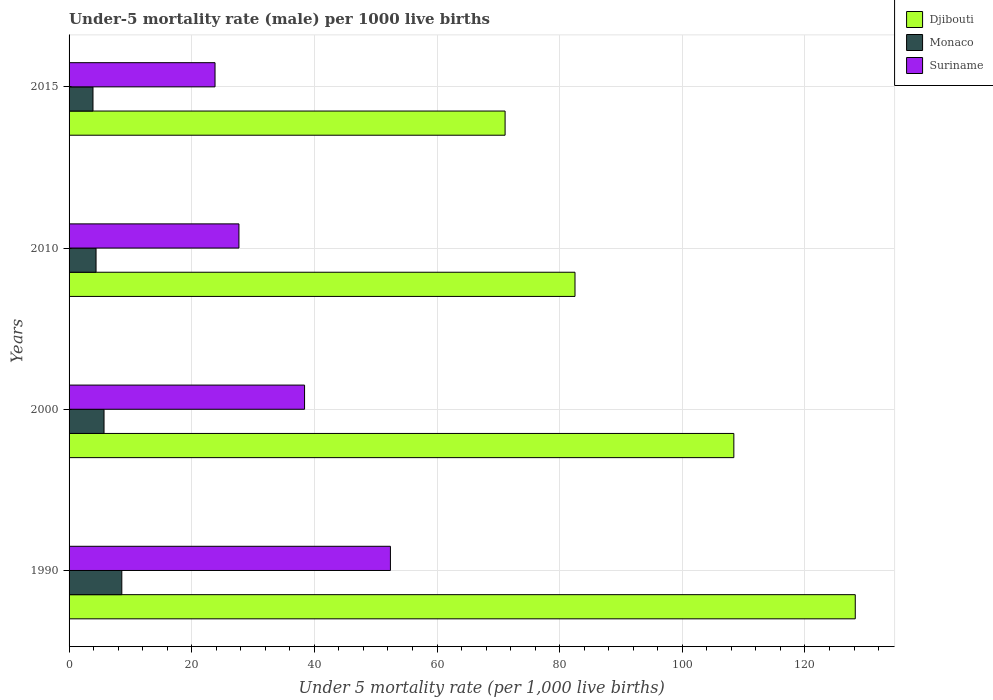How many different coloured bars are there?
Offer a very short reply. 3. How many groups of bars are there?
Offer a terse response. 4. Are the number of bars per tick equal to the number of legend labels?
Ensure brevity in your answer.  Yes. What is the label of the 2nd group of bars from the top?
Make the answer very short. 2010. Across all years, what is the minimum under-five mortality rate in Suriname?
Offer a very short reply. 23.8. In which year was the under-five mortality rate in Monaco maximum?
Provide a short and direct response. 1990. In which year was the under-five mortality rate in Monaco minimum?
Keep it short and to the point. 2015. What is the total under-five mortality rate in Djibouti in the graph?
Your answer should be very brief. 390.2. What is the difference between the under-five mortality rate in Djibouti in 1990 and that in 2010?
Your answer should be very brief. 45.7. What is the difference between the under-five mortality rate in Djibouti in 1990 and the under-five mortality rate in Suriname in 2010?
Keep it short and to the point. 100.5. What is the average under-five mortality rate in Djibouti per year?
Give a very brief answer. 97.55. In the year 2000, what is the difference between the under-five mortality rate in Suriname and under-five mortality rate in Djibouti?
Your response must be concise. -70. What is the ratio of the under-five mortality rate in Monaco in 2010 to that in 2015?
Offer a very short reply. 1.13. Is the difference between the under-five mortality rate in Suriname in 1990 and 2015 greater than the difference between the under-five mortality rate in Djibouti in 1990 and 2015?
Ensure brevity in your answer.  No. What is the difference between the highest and the second highest under-five mortality rate in Djibouti?
Offer a very short reply. 19.8. What is the difference between the highest and the lowest under-five mortality rate in Suriname?
Provide a succinct answer. 28.6. Is the sum of the under-five mortality rate in Djibouti in 2000 and 2010 greater than the maximum under-five mortality rate in Monaco across all years?
Your answer should be compact. Yes. What does the 3rd bar from the top in 2000 represents?
Give a very brief answer. Djibouti. What does the 2nd bar from the bottom in 1990 represents?
Ensure brevity in your answer.  Monaco. What is the difference between two consecutive major ticks on the X-axis?
Make the answer very short. 20. Does the graph contain grids?
Give a very brief answer. Yes. How many legend labels are there?
Make the answer very short. 3. What is the title of the graph?
Give a very brief answer. Under-5 mortality rate (male) per 1000 live births. Does "Antigua and Barbuda" appear as one of the legend labels in the graph?
Give a very brief answer. No. What is the label or title of the X-axis?
Provide a short and direct response. Under 5 mortality rate (per 1,0 live births). What is the Under 5 mortality rate (per 1,000 live births) in Djibouti in 1990?
Your answer should be compact. 128.2. What is the Under 5 mortality rate (per 1,000 live births) in Suriname in 1990?
Keep it short and to the point. 52.4. What is the Under 5 mortality rate (per 1,000 live births) in Djibouti in 2000?
Keep it short and to the point. 108.4. What is the Under 5 mortality rate (per 1,000 live births) in Monaco in 2000?
Offer a terse response. 5.7. What is the Under 5 mortality rate (per 1,000 live births) in Suriname in 2000?
Ensure brevity in your answer.  38.4. What is the Under 5 mortality rate (per 1,000 live births) in Djibouti in 2010?
Your response must be concise. 82.5. What is the Under 5 mortality rate (per 1,000 live births) in Monaco in 2010?
Your answer should be compact. 4.4. What is the Under 5 mortality rate (per 1,000 live births) in Suriname in 2010?
Your answer should be very brief. 27.7. What is the Under 5 mortality rate (per 1,000 live births) in Djibouti in 2015?
Provide a short and direct response. 71.1. What is the Under 5 mortality rate (per 1,000 live births) in Suriname in 2015?
Offer a very short reply. 23.8. Across all years, what is the maximum Under 5 mortality rate (per 1,000 live births) in Djibouti?
Offer a terse response. 128.2. Across all years, what is the maximum Under 5 mortality rate (per 1,000 live births) of Suriname?
Offer a terse response. 52.4. Across all years, what is the minimum Under 5 mortality rate (per 1,000 live births) of Djibouti?
Provide a succinct answer. 71.1. Across all years, what is the minimum Under 5 mortality rate (per 1,000 live births) of Monaco?
Provide a succinct answer. 3.9. Across all years, what is the minimum Under 5 mortality rate (per 1,000 live births) of Suriname?
Ensure brevity in your answer.  23.8. What is the total Under 5 mortality rate (per 1,000 live births) in Djibouti in the graph?
Provide a short and direct response. 390.2. What is the total Under 5 mortality rate (per 1,000 live births) in Monaco in the graph?
Give a very brief answer. 22.6. What is the total Under 5 mortality rate (per 1,000 live births) in Suriname in the graph?
Offer a terse response. 142.3. What is the difference between the Under 5 mortality rate (per 1,000 live births) of Djibouti in 1990 and that in 2000?
Keep it short and to the point. 19.8. What is the difference between the Under 5 mortality rate (per 1,000 live births) in Suriname in 1990 and that in 2000?
Your response must be concise. 14. What is the difference between the Under 5 mortality rate (per 1,000 live births) of Djibouti in 1990 and that in 2010?
Your answer should be very brief. 45.7. What is the difference between the Under 5 mortality rate (per 1,000 live births) of Monaco in 1990 and that in 2010?
Make the answer very short. 4.2. What is the difference between the Under 5 mortality rate (per 1,000 live births) of Suriname in 1990 and that in 2010?
Provide a short and direct response. 24.7. What is the difference between the Under 5 mortality rate (per 1,000 live births) of Djibouti in 1990 and that in 2015?
Your response must be concise. 57.1. What is the difference between the Under 5 mortality rate (per 1,000 live births) in Suriname in 1990 and that in 2015?
Your answer should be very brief. 28.6. What is the difference between the Under 5 mortality rate (per 1,000 live births) in Djibouti in 2000 and that in 2010?
Provide a short and direct response. 25.9. What is the difference between the Under 5 mortality rate (per 1,000 live births) of Suriname in 2000 and that in 2010?
Make the answer very short. 10.7. What is the difference between the Under 5 mortality rate (per 1,000 live births) in Djibouti in 2000 and that in 2015?
Your answer should be very brief. 37.3. What is the difference between the Under 5 mortality rate (per 1,000 live births) of Suriname in 2010 and that in 2015?
Offer a very short reply. 3.9. What is the difference between the Under 5 mortality rate (per 1,000 live births) of Djibouti in 1990 and the Under 5 mortality rate (per 1,000 live births) of Monaco in 2000?
Ensure brevity in your answer.  122.5. What is the difference between the Under 5 mortality rate (per 1,000 live births) of Djibouti in 1990 and the Under 5 mortality rate (per 1,000 live births) of Suriname in 2000?
Make the answer very short. 89.8. What is the difference between the Under 5 mortality rate (per 1,000 live births) of Monaco in 1990 and the Under 5 mortality rate (per 1,000 live births) of Suriname in 2000?
Offer a terse response. -29.8. What is the difference between the Under 5 mortality rate (per 1,000 live births) of Djibouti in 1990 and the Under 5 mortality rate (per 1,000 live births) of Monaco in 2010?
Keep it short and to the point. 123.8. What is the difference between the Under 5 mortality rate (per 1,000 live births) in Djibouti in 1990 and the Under 5 mortality rate (per 1,000 live births) in Suriname in 2010?
Give a very brief answer. 100.5. What is the difference between the Under 5 mortality rate (per 1,000 live births) of Monaco in 1990 and the Under 5 mortality rate (per 1,000 live births) of Suriname in 2010?
Ensure brevity in your answer.  -19.1. What is the difference between the Under 5 mortality rate (per 1,000 live births) of Djibouti in 1990 and the Under 5 mortality rate (per 1,000 live births) of Monaco in 2015?
Give a very brief answer. 124.3. What is the difference between the Under 5 mortality rate (per 1,000 live births) in Djibouti in 1990 and the Under 5 mortality rate (per 1,000 live births) in Suriname in 2015?
Offer a very short reply. 104.4. What is the difference between the Under 5 mortality rate (per 1,000 live births) of Monaco in 1990 and the Under 5 mortality rate (per 1,000 live births) of Suriname in 2015?
Your response must be concise. -15.2. What is the difference between the Under 5 mortality rate (per 1,000 live births) in Djibouti in 2000 and the Under 5 mortality rate (per 1,000 live births) in Monaco in 2010?
Give a very brief answer. 104. What is the difference between the Under 5 mortality rate (per 1,000 live births) of Djibouti in 2000 and the Under 5 mortality rate (per 1,000 live births) of Suriname in 2010?
Offer a terse response. 80.7. What is the difference between the Under 5 mortality rate (per 1,000 live births) in Monaco in 2000 and the Under 5 mortality rate (per 1,000 live births) in Suriname in 2010?
Give a very brief answer. -22. What is the difference between the Under 5 mortality rate (per 1,000 live births) in Djibouti in 2000 and the Under 5 mortality rate (per 1,000 live births) in Monaco in 2015?
Keep it short and to the point. 104.5. What is the difference between the Under 5 mortality rate (per 1,000 live births) in Djibouti in 2000 and the Under 5 mortality rate (per 1,000 live births) in Suriname in 2015?
Provide a succinct answer. 84.6. What is the difference between the Under 5 mortality rate (per 1,000 live births) of Monaco in 2000 and the Under 5 mortality rate (per 1,000 live births) of Suriname in 2015?
Your answer should be compact. -18.1. What is the difference between the Under 5 mortality rate (per 1,000 live births) of Djibouti in 2010 and the Under 5 mortality rate (per 1,000 live births) of Monaco in 2015?
Your answer should be compact. 78.6. What is the difference between the Under 5 mortality rate (per 1,000 live births) of Djibouti in 2010 and the Under 5 mortality rate (per 1,000 live births) of Suriname in 2015?
Ensure brevity in your answer.  58.7. What is the difference between the Under 5 mortality rate (per 1,000 live births) in Monaco in 2010 and the Under 5 mortality rate (per 1,000 live births) in Suriname in 2015?
Offer a terse response. -19.4. What is the average Under 5 mortality rate (per 1,000 live births) in Djibouti per year?
Offer a terse response. 97.55. What is the average Under 5 mortality rate (per 1,000 live births) in Monaco per year?
Make the answer very short. 5.65. What is the average Under 5 mortality rate (per 1,000 live births) in Suriname per year?
Ensure brevity in your answer.  35.58. In the year 1990, what is the difference between the Under 5 mortality rate (per 1,000 live births) in Djibouti and Under 5 mortality rate (per 1,000 live births) in Monaco?
Offer a very short reply. 119.6. In the year 1990, what is the difference between the Under 5 mortality rate (per 1,000 live births) of Djibouti and Under 5 mortality rate (per 1,000 live births) of Suriname?
Provide a short and direct response. 75.8. In the year 1990, what is the difference between the Under 5 mortality rate (per 1,000 live births) of Monaco and Under 5 mortality rate (per 1,000 live births) of Suriname?
Give a very brief answer. -43.8. In the year 2000, what is the difference between the Under 5 mortality rate (per 1,000 live births) of Djibouti and Under 5 mortality rate (per 1,000 live births) of Monaco?
Provide a succinct answer. 102.7. In the year 2000, what is the difference between the Under 5 mortality rate (per 1,000 live births) of Monaco and Under 5 mortality rate (per 1,000 live births) of Suriname?
Make the answer very short. -32.7. In the year 2010, what is the difference between the Under 5 mortality rate (per 1,000 live births) in Djibouti and Under 5 mortality rate (per 1,000 live births) in Monaco?
Offer a terse response. 78.1. In the year 2010, what is the difference between the Under 5 mortality rate (per 1,000 live births) in Djibouti and Under 5 mortality rate (per 1,000 live births) in Suriname?
Provide a short and direct response. 54.8. In the year 2010, what is the difference between the Under 5 mortality rate (per 1,000 live births) of Monaco and Under 5 mortality rate (per 1,000 live births) of Suriname?
Offer a terse response. -23.3. In the year 2015, what is the difference between the Under 5 mortality rate (per 1,000 live births) of Djibouti and Under 5 mortality rate (per 1,000 live births) of Monaco?
Give a very brief answer. 67.2. In the year 2015, what is the difference between the Under 5 mortality rate (per 1,000 live births) in Djibouti and Under 5 mortality rate (per 1,000 live births) in Suriname?
Keep it short and to the point. 47.3. In the year 2015, what is the difference between the Under 5 mortality rate (per 1,000 live births) of Monaco and Under 5 mortality rate (per 1,000 live births) of Suriname?
Make the answer very short. -19.9. What is the ratio of the Under 5 mortality rate (per 1,000 live births) in Djibouti in 1990 to that in 2000?
Offer a terse response. 1.18. What is the ratio of the Under 5 mortality rate (per 1,000 live births) of Monaco in 1990 to that in 2000?
Ensure brevity in your answer.  1.51. What is the ratio of the Under 5 mortality rate (per 1,000 live births) in Suriname in 1990 to that in 2000?
Provide a short and direct response. 1.36. What is the ratio of the Under 5 mortality rate (per 1,000 live births) in Djibouti in 1990 to that in 2010?
Provide a short and direct response. 1.55. What is the ratio of the Under 5 mortality rate (per 1,000 live births) in Monaco in 1990 to that in 2010?
Provide a short and direct response. 1.95. What is the ratio of the Under 5 mortality rate (per 1,000 live births) of Suriname in 1990 to that in 2010?
Offer a terse response. 1.89. What is the ratio of the Under 5 mortality rate (per 1,000 live births) of Djibouti in 1990 to that in 2015?
Your answer should be very brief. 1.8. What is the ratio of the Under 5 mortality rate (per 1,000 live births) in Monaco in 1990 to that in 2015?
Keep it short and to the point. 2.21. What is the ratio of the Under 5 mortality rate (per 1,000 live births) of Suriname in 1990 to that in 2015?
Your response must be concise. 2.2. What is the ratio of the Under 5 mortality rate (per 1,000 live births) in Djibouti in 2000 to that in 2010?
Your response must be concise. 1.31. What is the ratio of the Under 5 mortality rate (per 1,000 live births) in Monaco in 2000 to that in 2010?
Your answer should be compact. 1.3. What is the ratio of the Under 5 mortality rate (per 1,000 live births) in Suriname in 2000 to that in 2010?
Give a very brief answer. 1.39. What is the ratio of the Under 5 mortality rate (per 1,000 live births) in Djibouti in 2000 to that in 2015?
Your answer should be very brief. 1.52. What is the ratio of the Under 5 mortality rate (per 1,000 live births) of Monaco in 2000 to that in 2015?
Make the answer very short. 1.46. What is the ratio of the Under 5 mortality rate (per 1,000 live births) of Suriname in 2000 to that in 2015?
Make the answer very short. 1.61. What is the ratio of the Under 5 mortality rate (per 1,000 live births) in Djibouti in 2010 to that in 2015?
Your response must be concise. 1.16. What is the ratio of the Under 5 mortality rate (per 1,000 live births) in Monaco in 2010 to that in 2015?
Provide a succinct answer. 1.13. What is the ratio of the Under 5 mortality rate (per 1,000 live births) of Suriname in 2010 to that in 2015?
Your answer should be very brief. 1.16. What is the difference between the highest and the second highest Under 5 mortality rate (per 1,000 live births) of Djibouti?
Keep it short and to the point. 19.8. What is the difference between the highest and the lowest Under 5 mortality rate (per 1,000 live births) in Djibouti?
Offer a terse response. 57.1. What is the difference between the highest and the lowest Under 5 mortality rate (per 1,000 live births) of Suriname?
Provide a succinct answer. 28.6. 